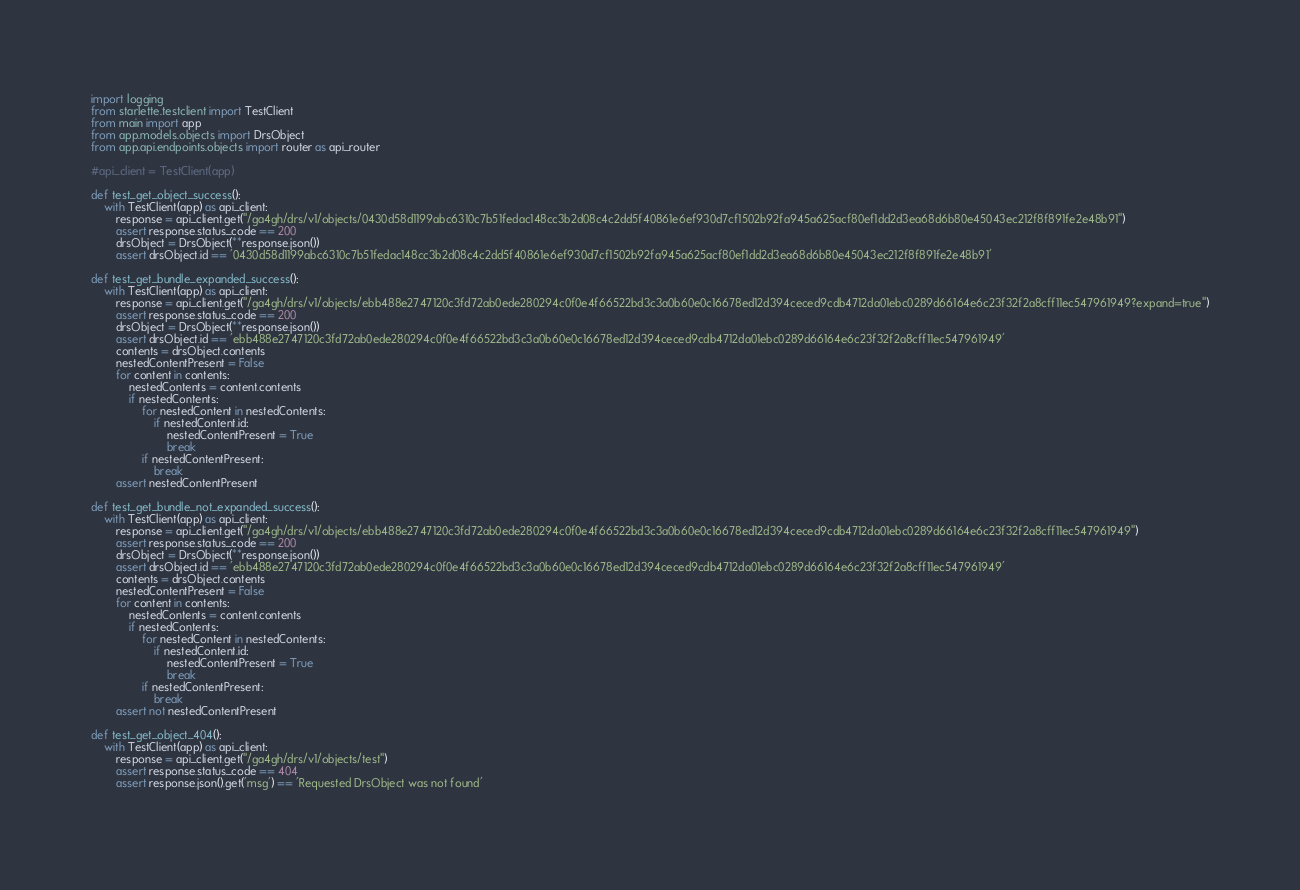<code> <loc_0><loc_0><loc_500><loc_500><_Python_>import logging
from starlette.testclient import TestClient
from main import app
from app.models.objects import DrsObject
from app.api.endpoints.objects import router as api_router

#api_client = TestClient(app)

def test_get_object_success():
    with TestClient(app) as api_client:
        response = api_client.get("/ga4gh/drs/v1/objects/0430d58d1199abc6310c7b51fedac148cc3b2d08c4c2dd5f40861e6ef930d7cf1502b92fa945a625acf80ef1dd2d3ea68d6b80e45043ec212f8f891fe2e48b91")
        assert response.status_code == 200
        drsObject = DrsObject(**response.json())
        assert drsObject.id == '0430d58d1199abc6310c7b51fedac148cc3b2d08c4c2dd5f40861e6ef930d7cf1502b92fa945a625acf80ef1dd2d3ea68d6b80e45043ec212f8f891fe2e48b91'

def test_get_bundle_expanded_success():
    with TestClient(app) as api_client:
        response = api_client.get("/ga4gh/drs/v1/objects/ebb488e2747120c3fd72ab0ede280294c0f0e4f66522bd3c3a0b60e0c16678ed12d394ceced9cdb4712da01ebc0289d66164e6c23f32f2a8cff11ec547961949?expand=true")
        assert response.status_code == 200
        drsObject = DrsObject(**response.json())
        assert drsObject.id == 'ebb488e2747120c3fd72ab0ede280294c0f0e4f66522bd3c3a0b60e0c16678ed12d394ceced9cdb4712da01ebc0289d66164e6c23f32f2a8cff11ec547961949'
        contents = drsObject.contents
        nestedContentPresent = False
        for content in contents:
            nestedContents = content.contents
            if nestedContents:
                for nestedContent in nestedContents:
                    if nestedContent.id:
                        nestedContentPresent = True
                        break
                if nestedContentPresent:
                    break
        assert nestedContentPresent     

def test_get_bundle_not_expanded_success():
    with TestClient(app) as api_client:
        response = api_client.get("/ga4gh/drs/v1/objects/ebb488e2747120c3fd72ab0ede280294c0f0e4f66522bd3c3a0b60e0c16678ed12d394ceced9cdb4712da01ebc0289d66164e6c23f32f2a8cff11ec547961949")
        assert response.status_code == 200
        drsObject = DrsObject(**response.json())
        assert drsObject.id == 'ebb488e2747120c3fd72ab0ede280294c0f0e4f66522bd3c3a0b60e0c16678ed12d394ceced9cdb4712da01ebc0289d66164e6c23f32f2a8cff11ec547961949'
        contents = drsObject.contents
        nestedContentPresent = False
        for content in contents:
            nestedContents = content.contents
            if nestedContents:
                for nestedContent in nestedContents:
                    if nestedContent.id:
                        nestedContentPresent = True
                        break
                if nestedContentPresent:
                    break
        assert not nestedContentPresent 

def test_get_object_404():
    with TestClient(app) as api_client:
        response = api_client.get("/ga4gh/drs/v1/objects/test")
        assert response.status_code == 404
        assert response.json().get('msg') == 'Requested DrsObject was not found'
    
</code> 